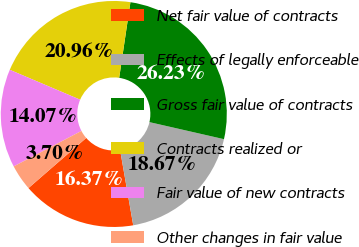Convert chart to OTSL. <chart><loc_0><loc_0><loc_500><loc_500><pie_chart><fcel>Net fair value of contracts<fcel>Effects of legally enforceable<fcel>Gross fair value of contracts<fcel>Contracts realized or<fcel>Fair value of new contracts<fcel>Other changes in fair value<nl><fcel>16.37%<fcel>18.67%<fcel>26.23%<fcel>20.96%<fcel>14.07%<fcel>3.7%<nl></chart> 